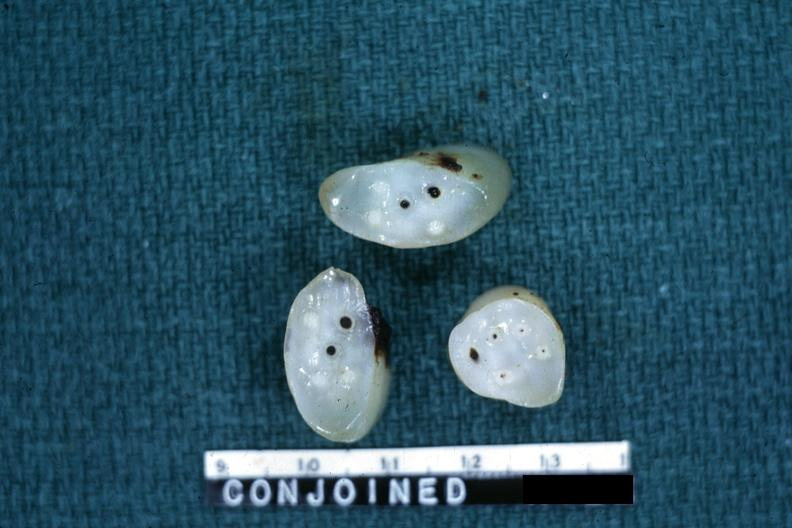what is present?
Answer the question using a single word or phrase. Umbilical cord 